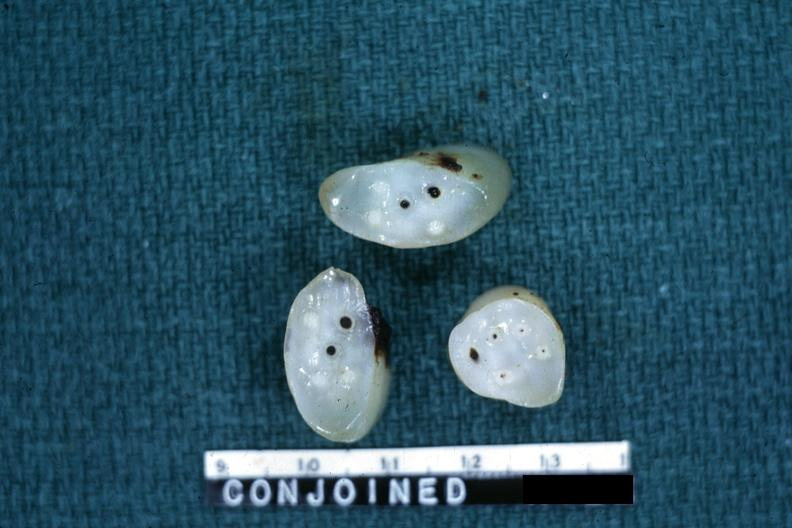what is present?
Answer the question using a single word or phrase. Umbilical cord 